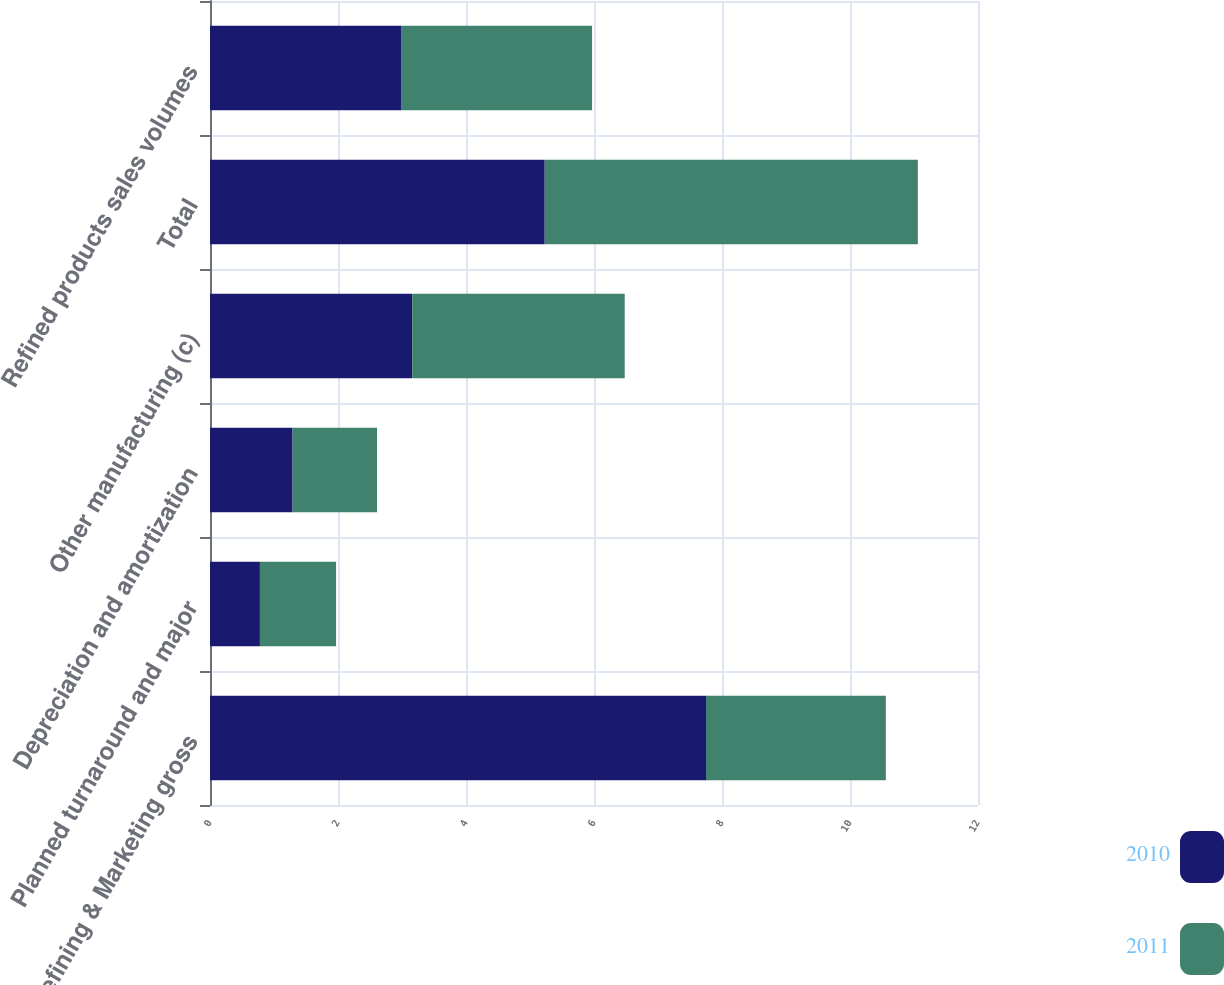Convert chart. <chart><loc_0><loc_0><loc_500><loc_500><stacked_bar_chart><ecel><fcel>Refining & Marketing gross<fcel>Planned turnaround and major<fcel>Depreciation and amortization<fcel>Other manufacturing (c)<fcel>Total<fcel>Refined products sales volumes<nl><fcel>2010<fcel>7.75<fcel>0.78<fcel>1.29<fcel>3.16<fcel>5.23<fcel>2.985<nl><fcel>2011<fcel>2.81<fcel>1.19<fcel>1.32<fcel>3.32<fcel>5.83<fcel>2.985<nl></chart> 